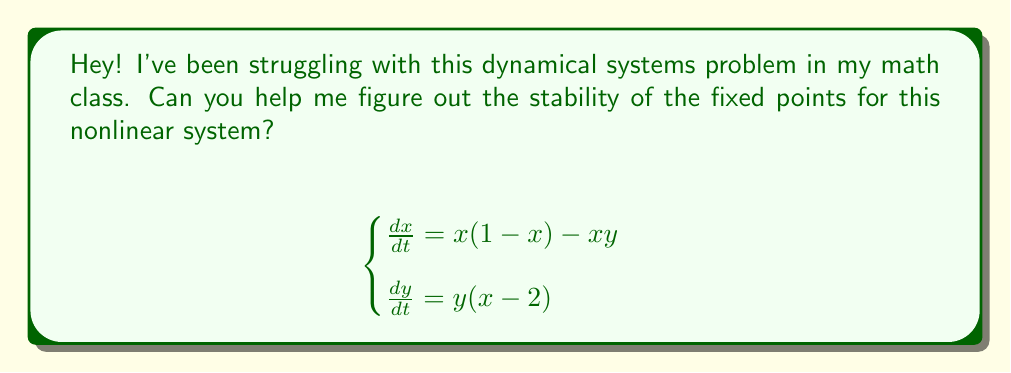Give your solution to this math problem. Sure, I'd be happy to help! Let's approach this step-by-step:

1) First, we need to find the fixed points. These are points where $\frac{dx}{dt} = \frac{dy}{dt} = 0$.

2) From $\frac{dy}{dt} = y(x-2) = 0$, we get either $y=0$ or $x=2$.

3) If $y=0$, then from $\frac{dx}{dt} = x(1-x) = 0$, we get $x=0$ or $x=1$.

4) If $x=2$, then from $\frac{dx}{dt} = x(1-x) - xy = 0$, we get $2(1-2) - 2y = 0$, so $y = -\frac{1}{2}$.

5) Therefore, our fixed points are $(0,0)$, $(1,0)$, and $(2,-\frac{1}{2})$.

6) To determine stability, we need to find the Jacobian matrix and evaluate it at each fixed point:

   $$J = \begin{bmatrix}
   1-2x-y & -x \\
   y & x-2
   \end{bmatrix}$$

7) For $(0,0)$:
   $$J(0,0) = \begin{bmatrix}
   1 & 0 \\
   0 & -2
   \end{bmatrix}$$
   Eigenvalues are 1 and -2. Since one is positive, this is an unstable saddle point.

8) For $(1,0)$:
   $$J(1,0) = \begin{bmatrix}
   -1 & -1 \\
   0 & -1
   \end{bmatrix}$$
   Eigenvalues are both -1. This is a stable node.

9) For $(2,-\frac{1}{2})$:
   $$J(2,-\frac{1}{2}) = \begin{bmatrix}
   -2 & -2 \\
   -\frac{1}{2} & 0
   \end{bmatrix}$$
   Eigenvalues are $-1 \pm i$. This is a stable spiral point.
Answer: $(0,0)$: unstable saddle, $(1,0)$: stable node, $(2,-\frac{1}{2})$: stable spiral 